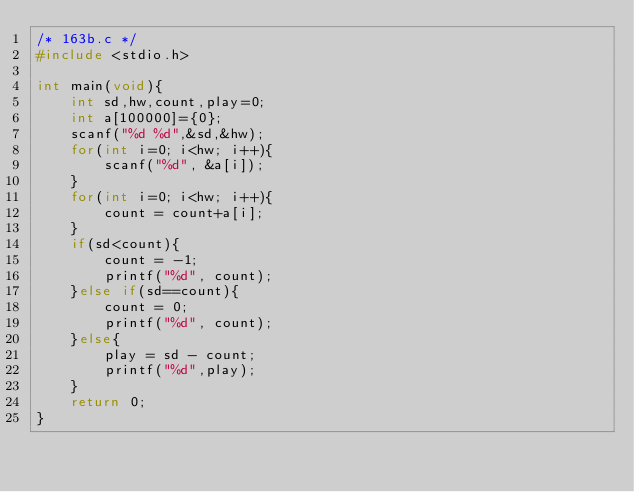<code> <loc_0><loc_0><loc_500><loc_500><_C_>/* 163b.c */
#include <stdio.h>

int main(void){
    int sd,hw,count,play=0;
    int a[100000]={0};
    scanf("%d %d",&sd,&hw);
    for(int i=0; i<hw; i++){
        scanf("%d", &a[i]);
    }
    for(int i=0; i<hw; i++){
        count = count+a[i];
    }
    if(sd<count){
        count = -1;
        printf("%d", count);
    }else if(sd==count){
        count = 0;
        printf("%d", count);
    }else{
        play = sd - count;
        printf("%d",play);
    }
    return 0;
}</code> 